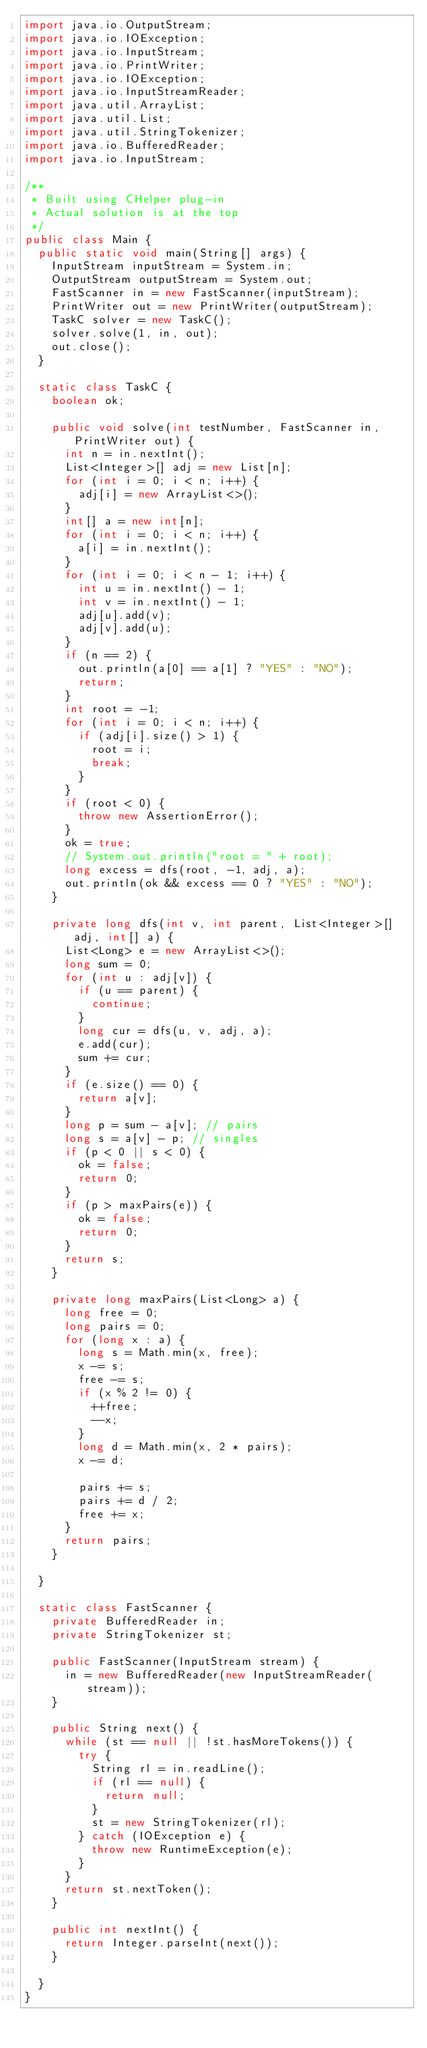<code> <loc_0><loc_0><loc_500><loc_500><_Java_>import java.io.OutputStream;
import java.io.IOException;
import java.io.InputStream;
import java.io.PrintWriter;
import java.io.IOException;
import java.io.InputStreamReader;
import java.util.ArrayList;
import java.util.List;
import java.util.StringTokenizer;
import java.io.BufferedReader;
import java.io.InputStream;

/**
 * Built using CHelper plug-in
 * Actual solution is at the top
 */
public class Main {
	public static void main(String[] args) {
		InputStream inputStream = System.in;
		OutputStream outputStream = System.out;
		FastScanner in = new FastScanner(inputStream);
		PrintWriter out = new PrintWriter(outputStream);
		TaskC solver = new TaskC();
		solver.solve(1, in, out);
		out.close();
	}

	static class TaskC {
		boolean ok;

		public void solve(int testNumber, FastScanner in, PrintWriter out) {
			int n = in.nextInt();
			List<Integer>[] adj = new List[n];
			for (int i = 0; i < n; i++) {
				adj[i] = new ArrayList<>();
			}
			int[] a = new int[n];
			for (int i = 0; i < n; i++) {
				a[i] = in.nextInt();
			}
			for (int i = 0; i < n - 1; i++) {
				int u = in.nextInt() - 1;
				int v = in.nextInt() - 1;
				adj[u].add(v);
				adj[v].add(u);
			}
			if (n == 2) {
				out.println(a[0] == a[1] ? "YES" : "NO");
				return;
			}
			int root = -1;
			for (int i = 0; i < n; i++) {
				if (adj[i].size() > 1) {
					root = i;
					break;
				}
			}
			if (root < 0) {
				throw new AssertionError();
			}
			ok = true;
			// System.out.println("root = " + root);
			long excess = dfs(root, -1, adj, a);
			out.println(ok && excess == 0 ? "YES" : "NO");
		}

		private long dfs(int v, int parent, List<Integer>[] adj, int[] a) {
			List<Long> e = new ArrayList<>();
			long sum = 0;
			for (int u : adj[v]) {
				if (u == parent) {
					continue;
				}
				long cur = dfs(u, v, adj, a);
				e.add(cur);
				sum += cur;
			}
			if (e.size() == 0) {
				return a[v];
			}
			long p = sum - a[v]; // pairs
			long s = a[v] - p; // singles
			if (p < 0 || s < 0) {
				ok = false;
				return 0;
			}
			if (p > maxPairs(e)) {
				ok = false;
				return 0;
			}
			return s;
		}

		private long maxPairs(List<Long> a) {
			long free = 0;
			long pairs = 0;
			for (long x : a) {
				long s = Math.min(x, free);
				x -= s;
				free -= s;
				if (x % 2 != 0) {
					++free;
					--x;
				}
				long d = Math.min(x, 2 * pairs);
				x -= d;

				pairs += s;
				pairs += d / 2;
				free += x;
			}
			return pairs;
		}

	}

	static class FastScanner {
		private BufferedReader in;
		private StringTokenizer st;

		public FastScanner(InputStream stream) {
			in = new BufferedReader(new InputStreamReader(stream));
		}

		public String next() {
			while (st == null || !st.hasMoreTokens()) {
				try {
					String rl = in.readLine();
					if (rl == null) {
						return null;
					}
					st = new StringTokenizer(rl);
				} catch (IOException e) {
					throw new RuntimeException(e);
				}
			}
			return st.nextToken();
		}

		public int nextInt() {
			return Integer.parseInt(next());
		}

	}
}

</code> 